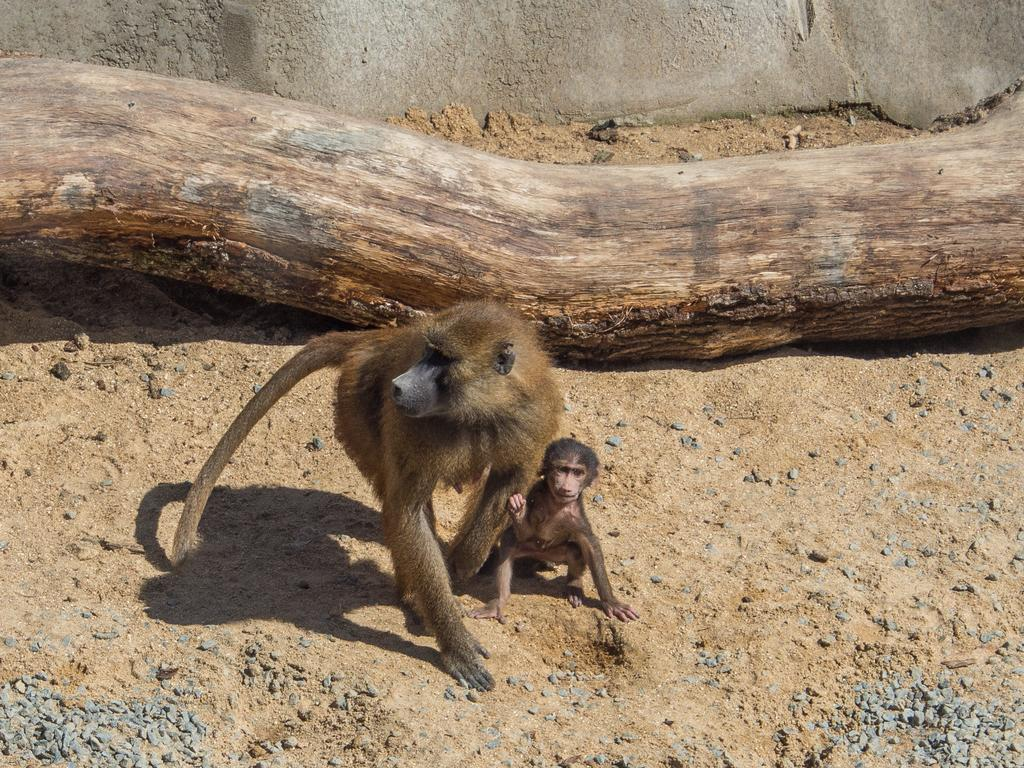What animals can be seen on the ground in the image? There are two monkeys on the ground in the image. What else is on the ground in the image? There are stones and a branch of a tree on the ground in the image. What structure is visible in the image? There is a wall visible in the image. What type of paint is being used by the monkeys in the image? There is no paint or painting activity depicted in the image; the monkeys are simply on the ground with stones and a branch. 